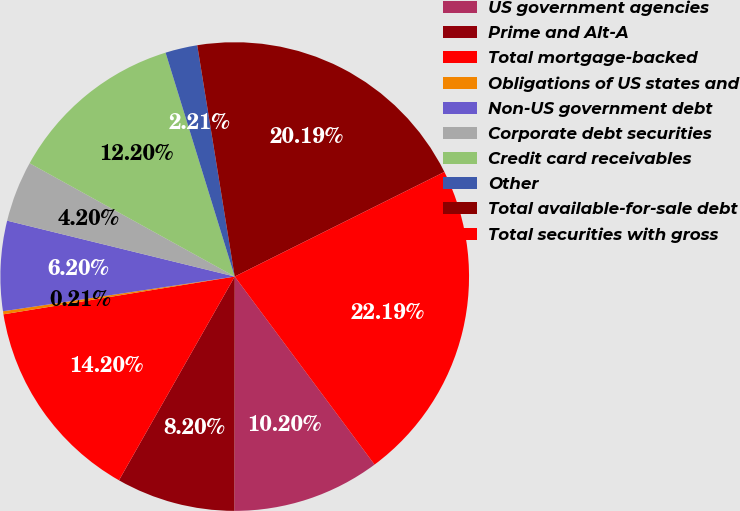Convert chart. <chart><loc_0><loc_0><loc_500><loc_500><pie_chart><fcel>US government agencies<fcel>Prime and Alt-A<fcel>Total mortgage-backed<fcel>Obligations of US states and<fcel>Non-US government debt<fcel>Corporate debt securities<fcel>Credit card receivables<fcel>Other<fcel>Total available-for-sale debt<fcel>Total securities with gross<nl><fcel>10.2%<fcel>8.2%<fcel>14.2%<fcel>0.21%<fcel>6.2%<fcel>4.2%<fcel>12.2%<fcel>2.21%<fcel>20.19%<fcel>22.19%<nl></chart> 